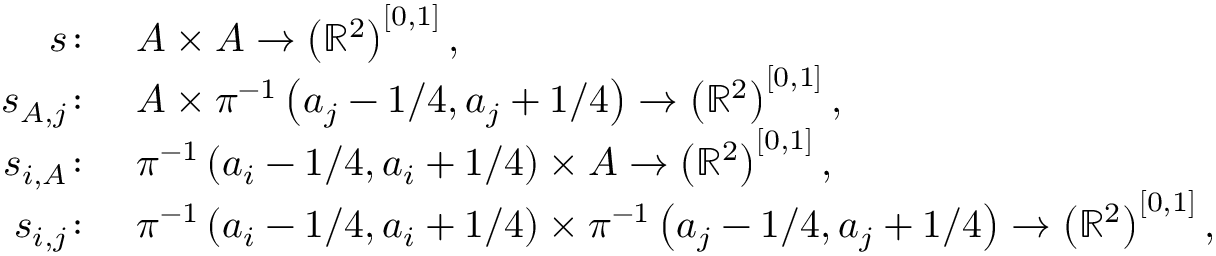Convert formula to latex. <formula><loc_0><loc_0><loc_500><loc_500>\begin{array} { r l } { s \colon } & { A \times A \to \left ( \mathbb { R } ^ { 2 } \right ) ^ { [ 0 , 1 ] } , } \\ { s _ { A , j } \colon } & { A \times \pi ^ { - 1 } \left ( a _ { j } - 1 / 4 , a _ { j } + 1 / 4 \right ) \to \left ( \mathbb { R } ^ { 2 } \right ) ^ { [ 0 , 1 ] } , } \\ { s _ { i , A } \colon } & { \pi ^ { - 1 } \left ( a _ { i } - 1 / 4 , a _ { i } + 1 / 4 \right ) \times A \to \left ( \mathbb { R } ^ { 2 } \right ) ^ { [ 0 , 1 ] } , } \\ { s _ { i , j } \colon } & { \pi ^ { - 1 } \left ( a _ { i } - 1 / 4 , a _ { i } + 1 / 4 \right ) \times \pi ^ { - 1 } \left ( a _ { j } - 1 / 4 , a _ { j } + 1 / 4 \right ) \to \left ( \mathbb { R } ^ { 2 } \right ) ^ { [ 0 , 1 ] } , } \end{array}</formula> 